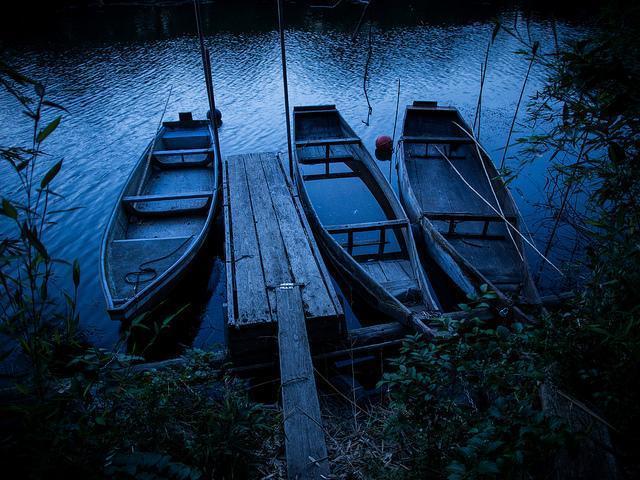How many boats are there?
Give a very brief answer. 3. How many boats are in the picture?
Give a very brief answer. 3. 